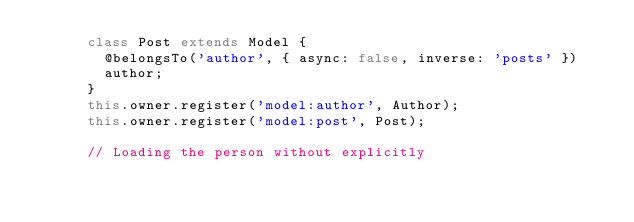<code> <loc_0><loc_0><loc_500><loc_500><_JavaScript_>      class Post extends Model {
        @belongsTo('author', { async: false, inverse: 'posts' })
        author;
      }
      this.owner.register('model:author', Author);
      this.owner.register('model:post', Post);

      // Loading the person without explicitly</code> 